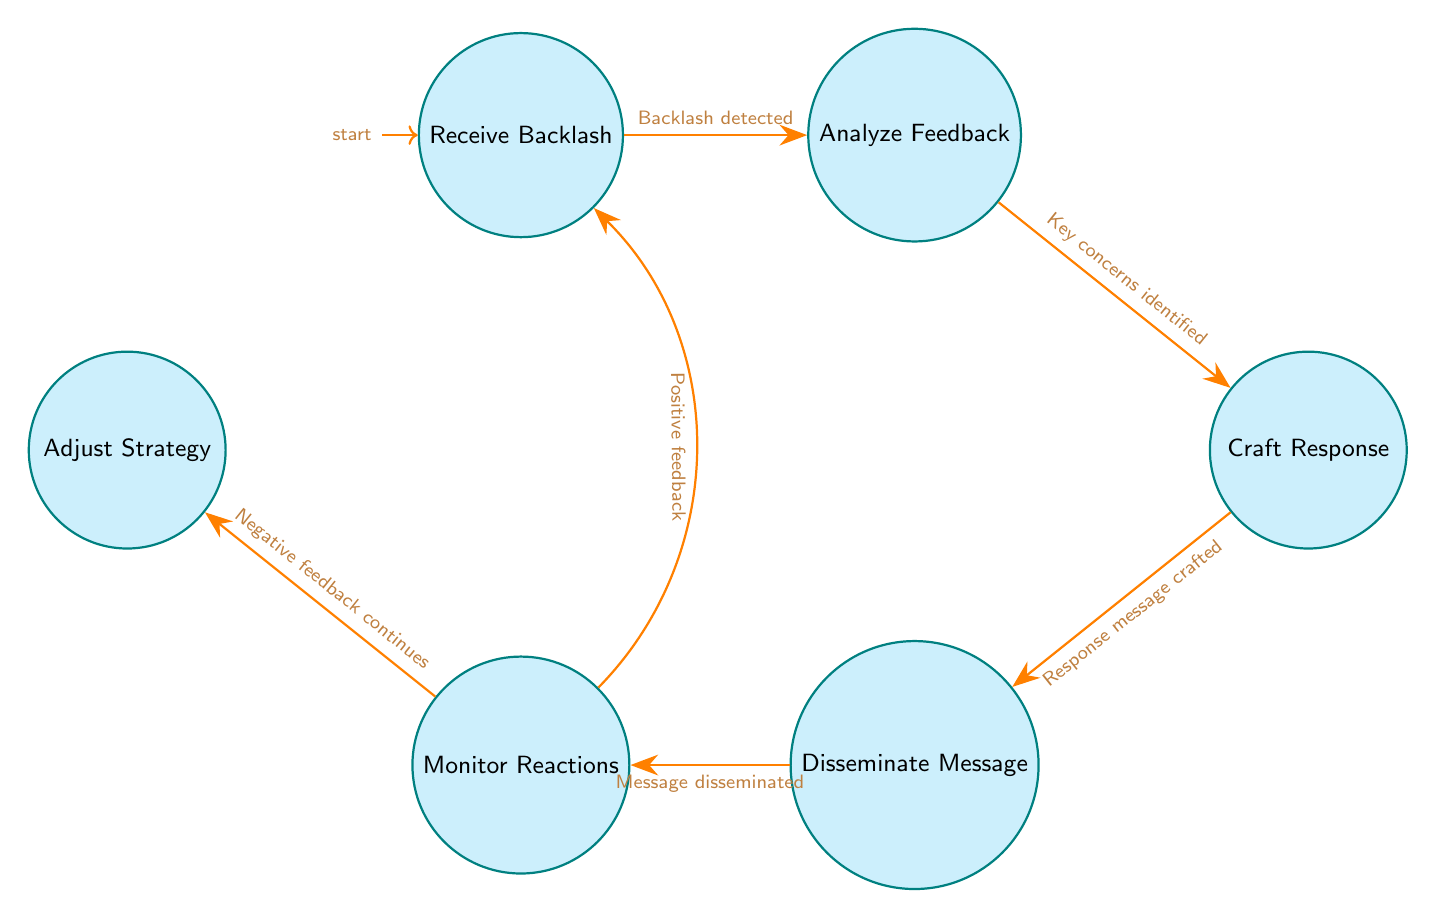What is the starting state in the diagram? The starting state is indicated by the initial marker on the "Receive Backlash" node, which signifies where the process begins.
Answer: Receive Backlash How many states are present in the diagram? By counting the nodes labeled in the diagram, we identify six distinct states: Receive Backlash, Analyze Feedback, Craft Response, Disseminate Message, Monitor Reactions, and Adjust Strategy.
Answer: 6 What transition occurs after "Craft Response"? The diagram shows that after the "Craft Response" state, the next transition occurs to the "Disseminate Message" state indicating that a crafted response is sent out.
Answer: Disseminate Message Which state follows "Analyze Feedback"? According to the flow, after "Analyze Feedback," the state transitioning next is "Craft Response," signifying that feedback analysis leads to crafting an appropriate response.
Answer: Craft Response What condition leads to the transition from "Monitor Reactions" to "Adjust Strategy"? The condition that triggers this transition is indicated as "Negative feedback continues." This implies that if ongoing reactions to the message are negative, the strategy needs adjustment.
Answer: Negative feedback continues If the feedback is positive, what is the next state? The diagram states that if positive feedback is received, the process loops back to the "Receive Backlash" state, indicating a return to monitoring backlash.
Answer: Receive Backlash How many transitions are there in total in the diagram? Counting all transitions between nodes, there are a total of six transitions defined by conditions that connect various states.
Answer: 6 What is the condition for moving from "Disseminate Message" to "Monitor Reactions"? The transition from "Disseminate Message" to "Monitor Reactions" takes place under the condition "Message disseminated," meaning once the message has gone out, reactions can be monitored.
Answer: Message disseminated What is the last state in the flow before adjusting the strategy? The last state prior to potentially adjusting the strategy is "Monitor Reactions," indicating that reactions from the audience must first be monitored before any adjustments can be made.
Answer: Monitor Reactions 